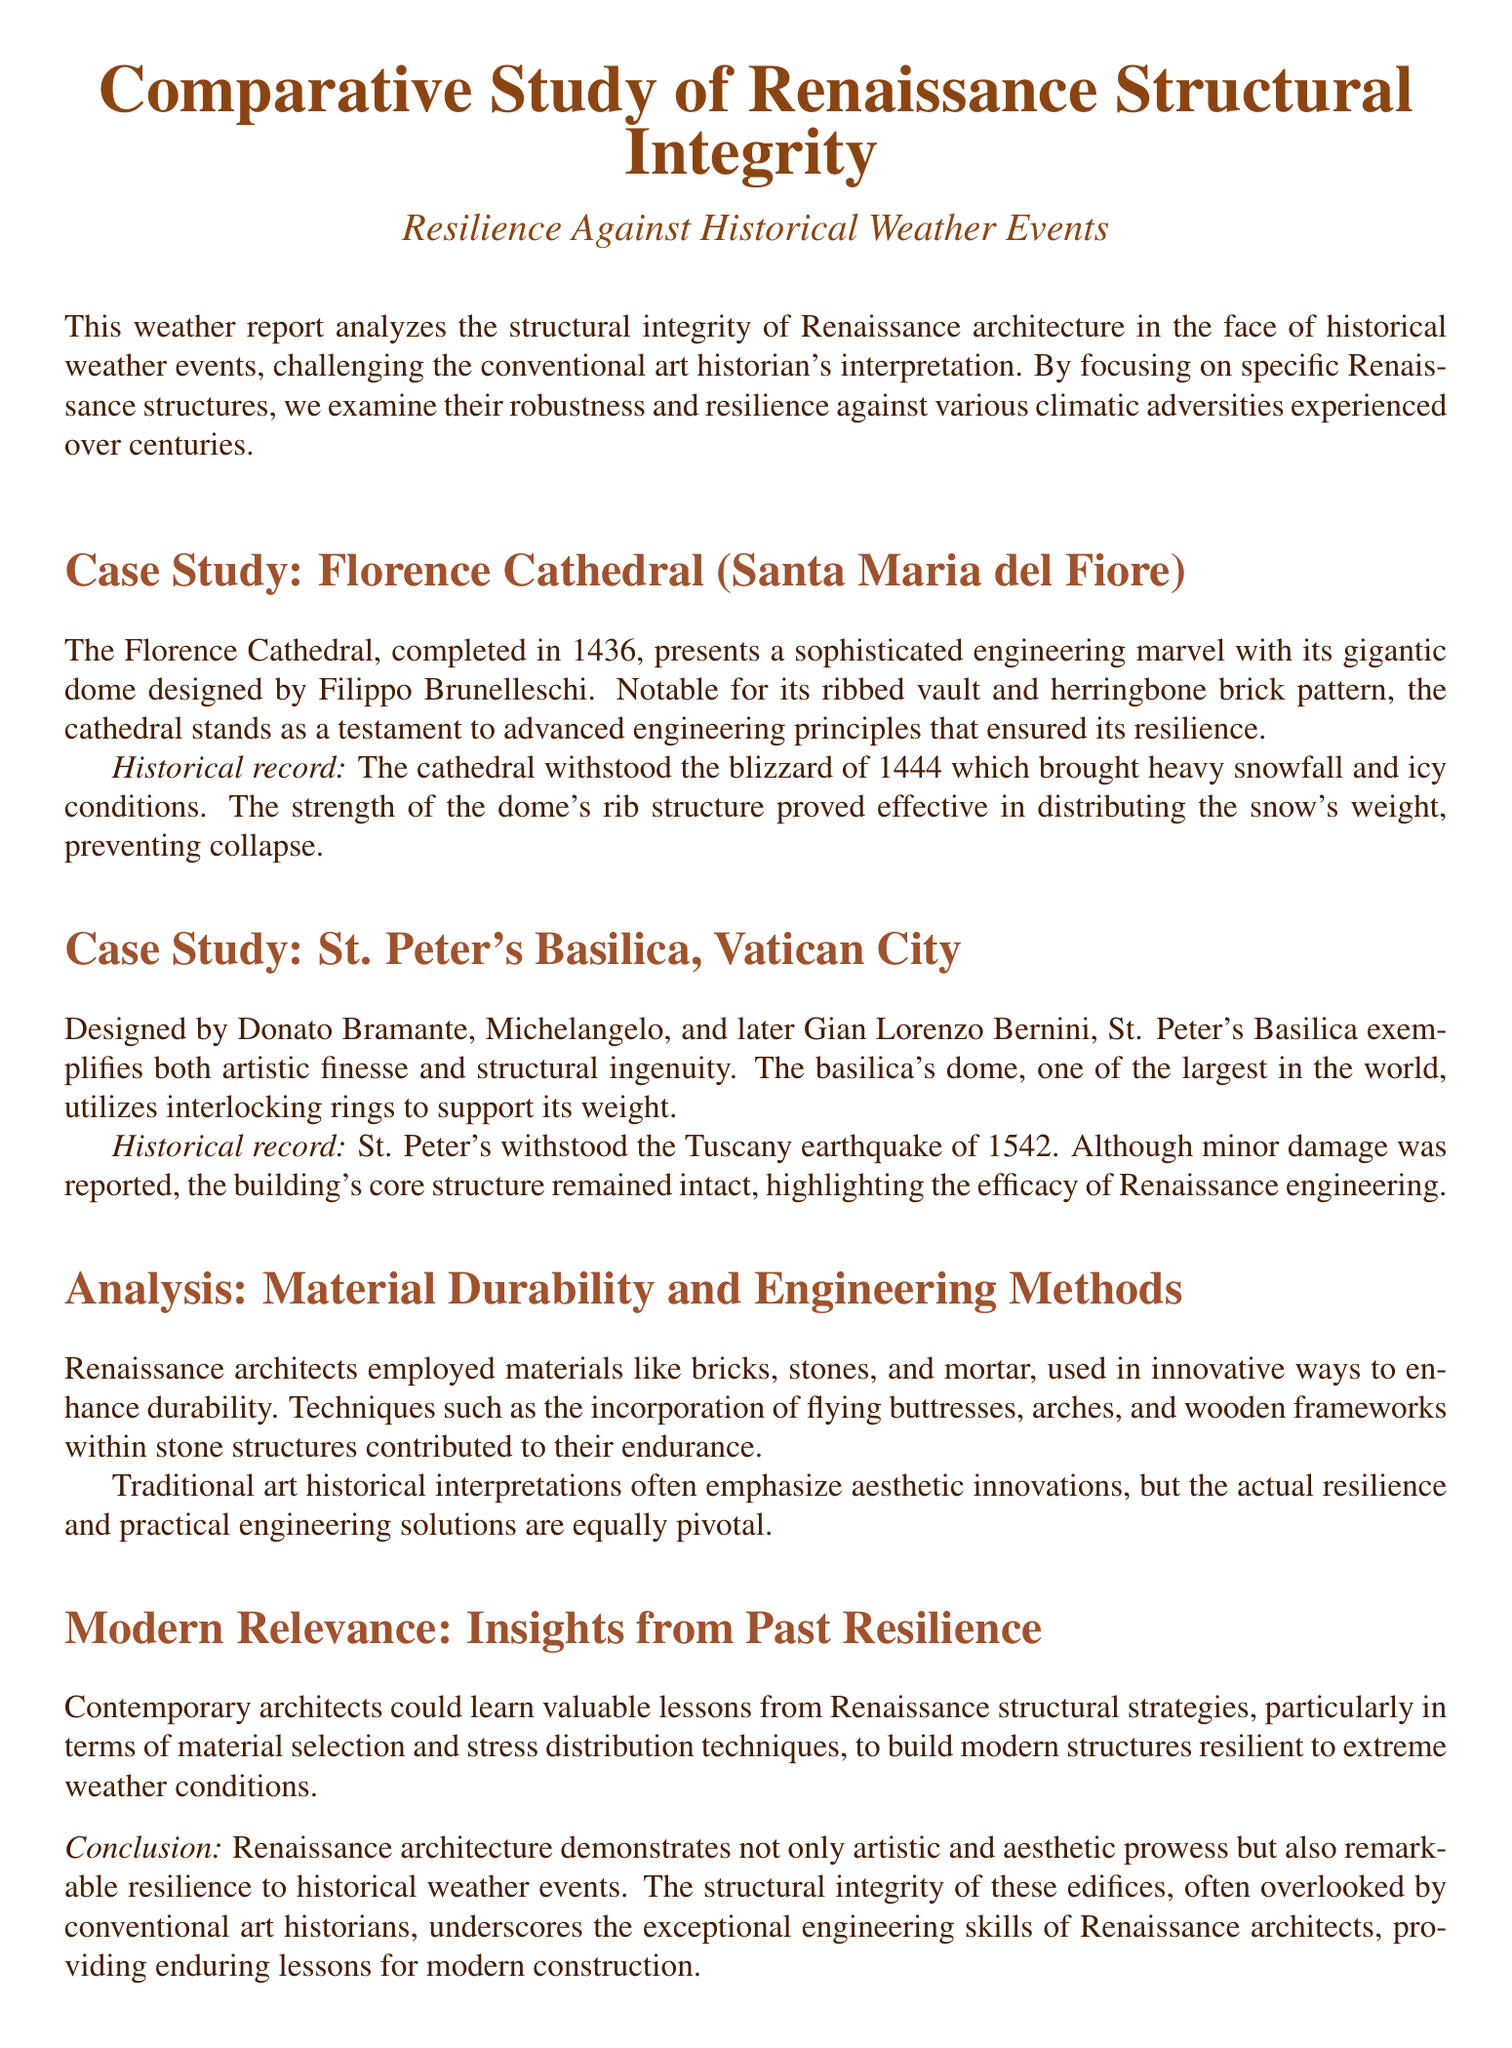What is the completion year of Florence Cathedral? The document states that the Florence Cathedral was completed in 1436.
Answer: 1436 What event did the Florence Cathedral withstand? The document mentions that the Florence Cathedral withstood the blizzard of 1444.
Answer: blizzard of 1444 Who designed St. Peter's Basilica? The document lists Donato Bramante, Michelangelo, and Gian Lorenzo Bernini as designers of St. Peter's Basilica.
Answer: Donato Bramante, Michelangelo, Gian Lorenzo Bernini What natural disaster affected St. Peter's Basilica? The document records that St. Peter's Basilica withstood the Tuscany earthquake of 1542.
Answer: Tuscany earthquake of 1542 What material did Renaissance architects commonly use? The document states that Renaissance architects employed bricks, stones, and mortar.
Answer: bricks, stones, and mortar What is the significance of flying buttresses mentioned in the document? The document indicates that flying buttresses were utilized to enhance structural durability in Renaissance architecture.
Answer: enhance structural durability How do Renaissance structures compare to modern construction? The document suggests that contemporary architects could learn valuable lessons from Renaissance structural strategies.
Answer: learn valuable lessons What does the conclusion highlight about Renaissance architecture? The conclusion emphasizes the remarkable resilience of Renaissance architecture to historical weather events.
Answer: resilience to historical weather events 